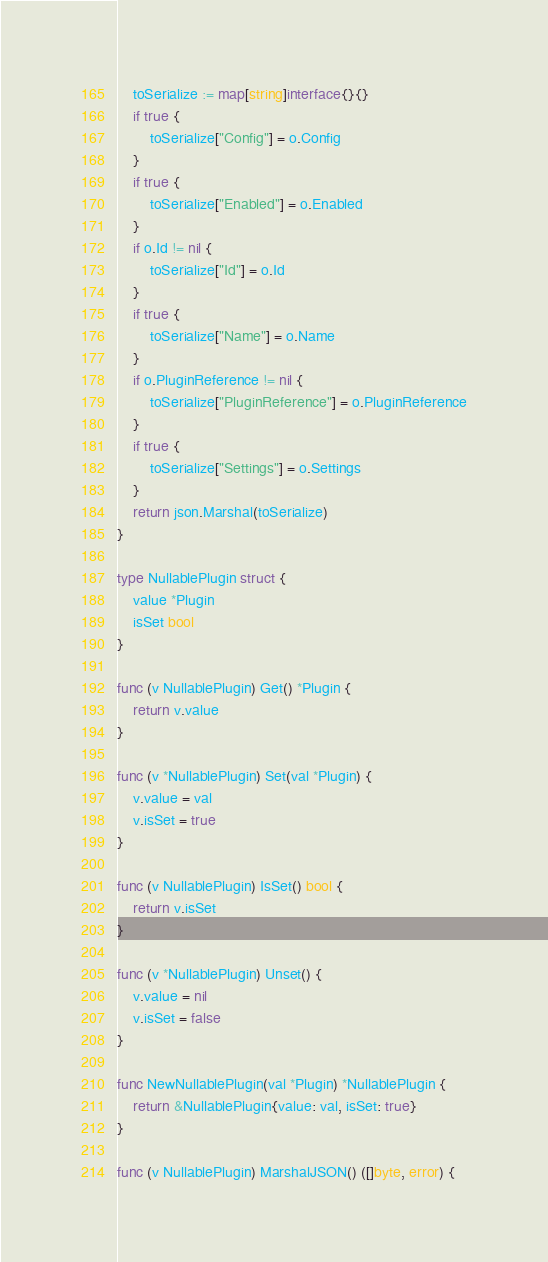<code> <loc_0><loc_0><loc_500><loc_500><_Go_>	toSerialize := map[string]interface{}{}
	if true {
		toSerialize["Config"] = o.Config
	}
	if true {
		toSerialize["Enabled"] = o.Enabled
	}
	if o.Id != nil {
		toSerialize["Id"] = o.Id
	}
	if true {
		toSerialize["Name"] = o.Name
	}
	if o.PluginReference != nil {
		toSerialize["PluginReference"] = o.PluginReference
	}
	if true {
		toSerialize["Settings"] = o.Settings
	}
	return json.Marshal(toSerialize)
}

type NullablePlugin struct {
	value *Plugin
	isSet bool
}

func (v NullablePlugin) Get() *Plugin {
	return v.value
}

func (v *NullablePlugin) Set(val *Plugin) {
	v.value = val
	v.isSet = true
}

func (v NullablePlugin) IsSet() bool {
	return v.isSet
}

func (v *NullablePlugin) Unset() {
	v.value = nil
	v.isSet = false
}

func NewNullablePlugin(val *Plugin) *NullablePlugin {
	return &NullablePlugin{value: val, isSet: true}
}

func (v NullablePlugin) MarshalJSON() ([]byte, error) {</code> 